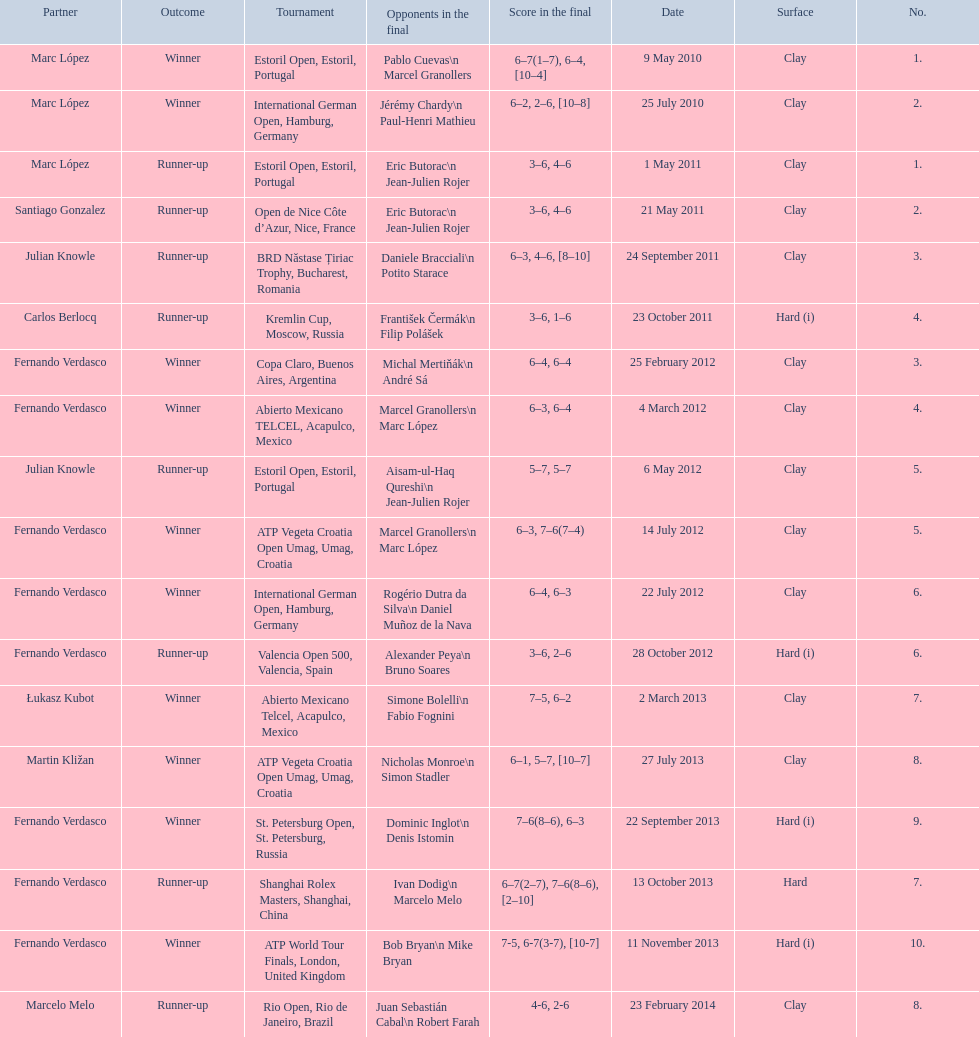What is the number of times a hard surface was used? 5. 